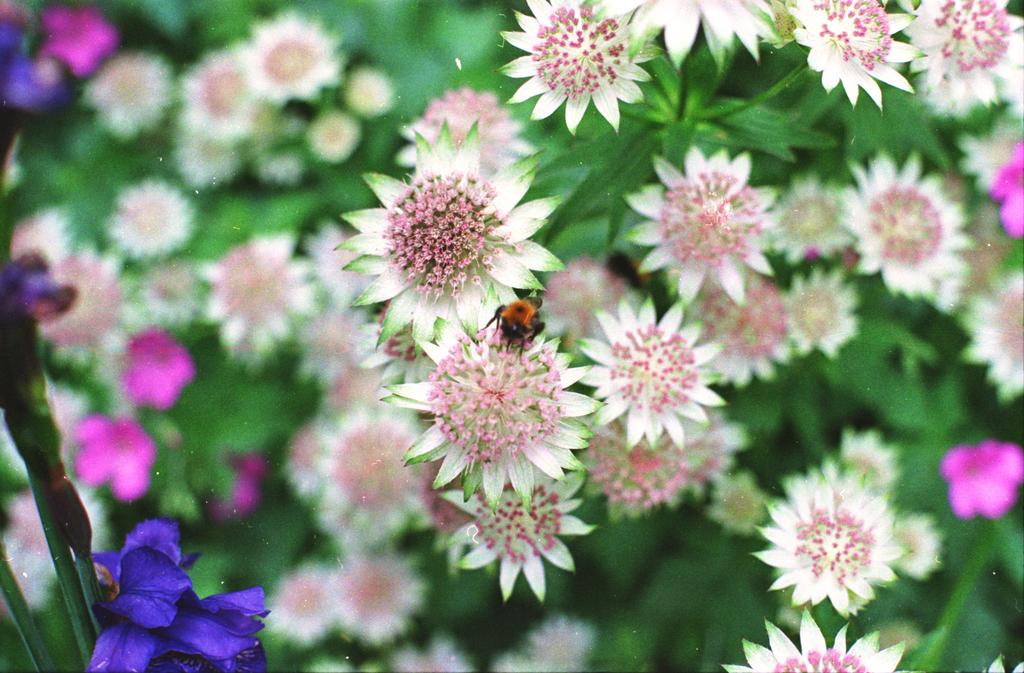What is on the flower in the image? There is an insect on a flower in the image. What can be observed about the plants in the image? There are plants with different colors of flowers in the image. Can you see any animals interacting with the insect on the flower in the image? There is no animal present in the image interacting with the insect on the flower. Is there a can visible in the image? There is no can present in the image. 